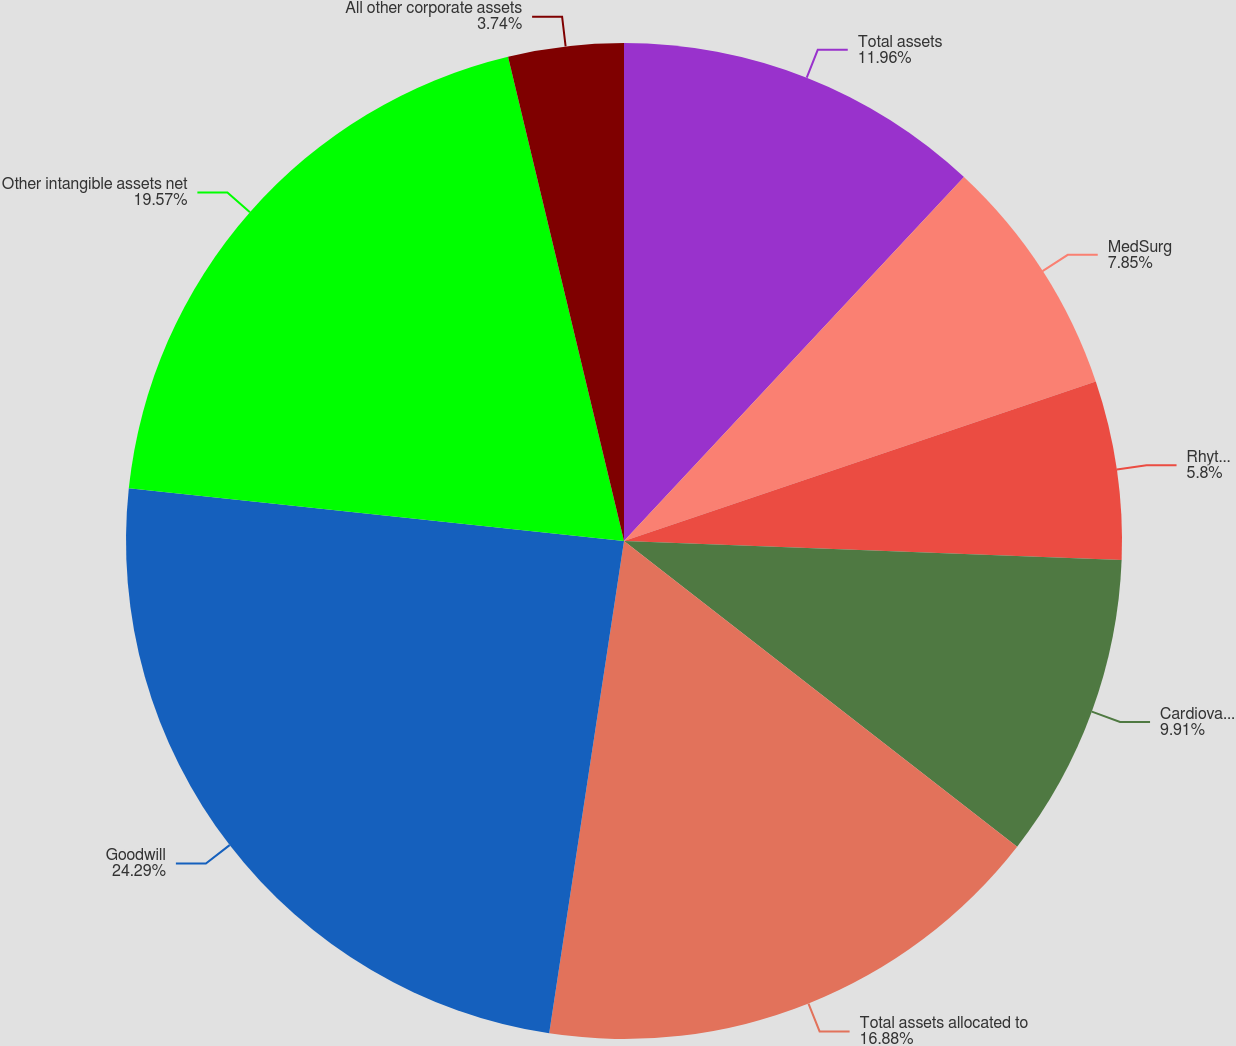Convert chart. <chart><loc_0><loc_0><loc_500><loc_500><pie_chart><fcel>Total assets<fcel>MedSurg<fcel>Rhythm and Neuro<fcel>Cardiovascular<fcel>Total assets allocated to<fcel>Goodwill<fcel>Other intangible assets net<fcel>All other corporate assets<nl><fcel>11.96%<fcel>7.85%<fcel>5.8%<fcel>9.91%<fcel>16.88%<fcel>24.29%<fcel>19.57%<fcel>3.74%<nl></chart> 